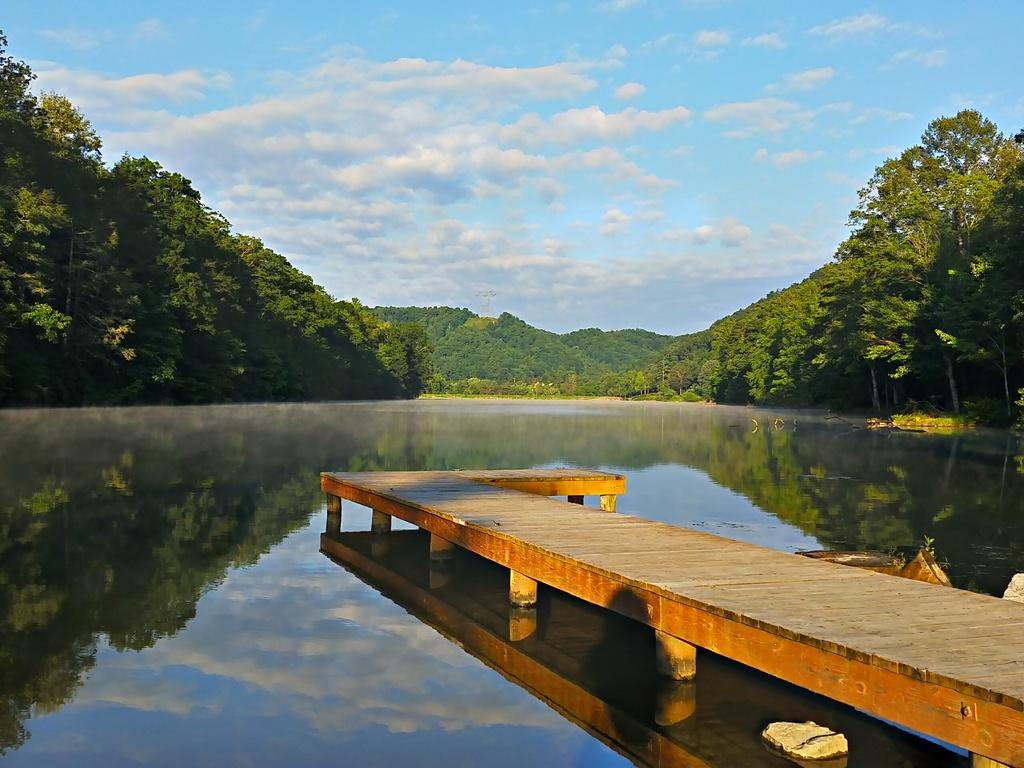What is the main structure in the center of the image? There is a wooden pier in the center of the image. What can be seen supporting the pier? There are poles in the image. What is visible in the background of the image? The sky, clouds, trees, and water are visible in the background of the image. Can you describe the objects in the image besides the pier and poles? There are a few other objects in the image, but their details are not clear from the provided facts. What type of jelly is being used to hold the drum in the image? There is no drum or jelly present in the image. 